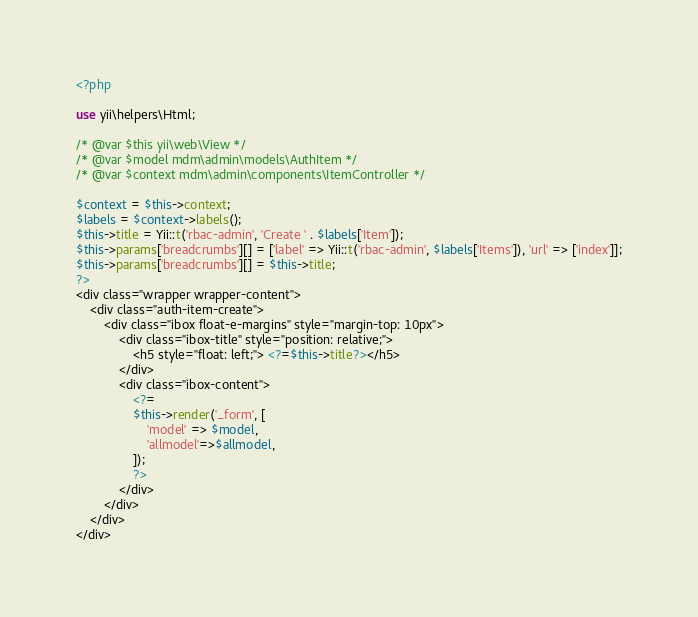<code> <loc_0><loc_0><loc_500><loc_500><_PHP_><?php

use yii\helpers\Html;

/* @var $this yii\web\View */
/* @var $model mdm\admin\models\AuthItem */
/* @var $context mdm\admin\components\ItemController */

$context = $this->context;
$labels = $context->labels();
$this->title = Yii::t('rbac-admin', 'Create ' . $labels['Item']);
$this->params['breadcrumbs'][] = ['label' => Yii::t('rbac-admin', $labels['Items']), 'url' => ['index']];
$this->params['breadcrumbs'][] = $this->title;
?>
<div class="wrapper wrapper-content">
    <div class="auth-item-create">
        <div class="ibox float-e-margins" style="margin-top: 10px">
            <div class="ibox-title" style="position: relative;">
                <h5 style="float: left;"> <?=$this->title?></h5>
            </div>
            <div class="ibox-content">
                <?=
                $this->render('_form', [
                    'model' => $model,
                    'allmodel'=>$allmodel,
                ]);
                ?>
            </div>
        </div>
    </div>
</div>
</code> 